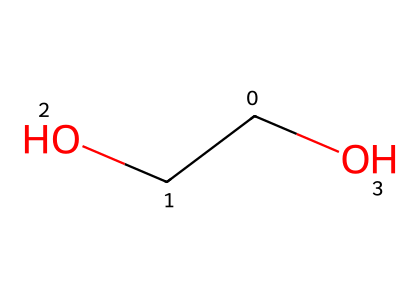How many carbon atoms are present in the molecule? The SMILES representation shows "C(CO)", which indicates that there is one carbon in the main chain and another in the side chain (OH group). Thus, there are two carbon atoms.
Answer: 2 What type of functional group is present in this chemical? The SMILES includes "CO", indicating the presence of a hydroxyl (OH) group attached to a carbon, which makes it an alcohol functional group.
Answer: alcohol How many hydrogen atoms are connected to the carbon atoms? Since each carbon can form four bonds, the carbon atoms in this molecule will bond with hydrogen atoms. Counting the hydrogens connected, there is a total of six hydrogen atoms connected to the two carbons in the structure.
Answer: 6 What is the total number of bonds in this molecule? The molecule has 2 carbon atoms, each typically bonding with other atoms. With each carbon bonded to hydroxyl, and hydrogen, the total number of bonds can be calculated as follows: each carbon connects to 3 hydrogen and 1 hydroxyl, leading to a total of 5 bonds, and the 2-carbon connection adds 1 more, giving 6 bonds.
Answer: 6 Does this molecule have any chiral centers? A chiral center is typically an atom, usually carbon, that has four different groups attached to it. In this molecule, the second carbon in the functional group has a hydroxyl group attached like one of its adjacent carbons, thus it does not have four distinct groups attached leading to no chiral centers.
Answer: no 